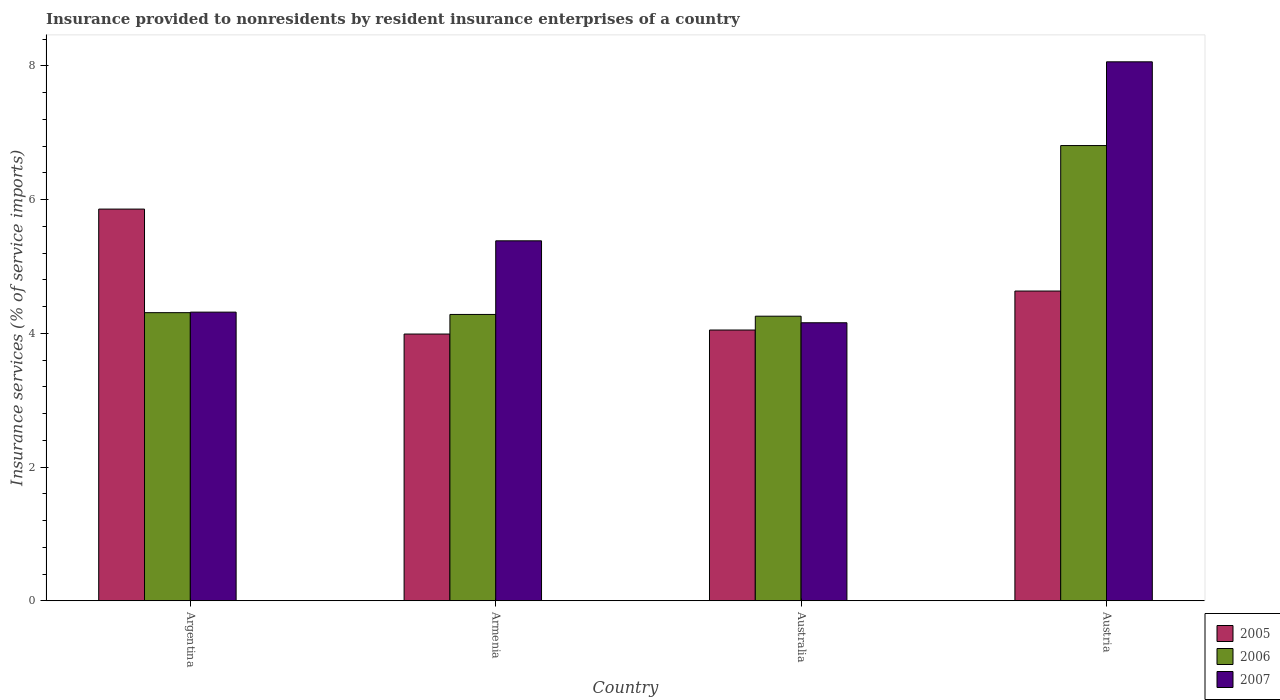How many groups of bars are there?
Your response must be concise. 4. Are the number of bars per tick equal to the number of legend labels?
Keep it short and to the point. Yes. Are the number of bars on each tick of the X-axis equal?
Make the answer very short. Yes. How many bars are there on the 2nd tick from the right?
Your answer should be very brief. 3. What is the label of the 2nd group of bars from the left?
Offer a very short reply. Armenia. In how many cases, is the number of bars for a given country not equal to the number of legend labels?
Keep it short and to the point. 0. What is the insurance provided to nonresidents in 2007 in Australia?
Provide a short and direct response. 4.16. Across all countries, what is the maximum insurance provided to nonresidents in 2005?
Make the answer very short. 5.86. Across all countries, what is the minimum insurance provided to nonresidents in 2006?
Offer a terse response. 4.26. In which country was the insurance provided to nonresidents in 2006 maximum?
Provide a succinct answer. Austria. In which country was the insurance provided to nonresidents in 2006 minimum?
Keep it short and to the point. Australia. What is the total insurance provided to nonresidents in 2006 in the graph?
Provide a short and direct response. 19.65. What is the difference between the insurance provided to nonresidents in 2006 in Armenia and that in Australia?
Your answer should be very brief. 0.03. What is the difference between the insurance provided to nonresidents in 2005 in Armenia and the insurance provided to nonresidents in 2007 in Argentina?
Provide a short and direct response. -0.33. What is the average insurance provided to nonresidents in 2007 per country?
Your answer should be compact. 5.48. What is the difference between the insurance provided to nonresidents of/in 2005 and insurance provided to nonresidents of/in 2007 in Australia?
Give a very brief answer. -0.11. What is the ratio of the insurance provided to nonresidents in 2005 in Armenia to that in Austria?
Ensure brevity in your answer.  0.86. Is the insurance provided to nonresidents in 2007 in Argentina less than that in Armenia?
Your response must be concise. Yes. What is the difference between the highest and the second highest insurance provided to nonresidents in 2005?
Your response must be concise. -0.58. What is the difference between the highest and the lowest insurance provided to nonresidents in 2006?
Provide a succinct answer. 2.55. In how many countries, is the insurance provided to nonresidents in 2007 greater than the average insurance provided to nonresidents in 2007 taken over all countries?
Your answer should be very brief. 1. Is the sum of the insurance provided to nonresidents in 2006 in Armenia and Austria greater than the maximum insurance provided to nonresidents in 2005 across all countries?
Your answer should be compact. Yes. What does the 1st bar from the right in Austria represents?
Give a very brief answer. 2007. How many bars are there?
Offer a terse response. 12. How many countries are there in the graph?
Keep it short and to the point. 4. What is the difference between two consecutive major ticks on the Y-axis?
Your response must be concise. 2. How many legend labels are there?
Provide a succinct answer. 3. What is the title of the graph?
Keep it short and to the point. Insurance provided to nonresidents by resident insurance enterprises of a country. Does "1964" appear as one of the legend labels in the graph?
Give a very brief answer. No. What is the label or title of the Y-axis?
Your response must be concise. Insurance services (% of service imports). What is the Insurance services (% of service imports) of 2005 in Argentina?
Offer a terse response. 5.86. What is the Insurance services (% of service imports) in 2006 in Argentina?
Your answer should be very brief. 4.31. What is the Insurance services (% of service imports) in 2007 in Argentina?
Make the answer very short. 4.32. What is the Insurance services (% of service imports) in 2005 in Armenia?
Offer a very short reply. 3.99. What is the Insurance services (% of service imports) of 2006 in Armenia?
Make the answer very short. 4.28. What is the Insurance services (% of service imports) of 2007 in Armenia?
Make the answer very short. 5.38. What is the Insurance services (% of service imports) in 2005 in Australia?
Provide a succinct answer. 4.05. What is the Insurance services (% of service imports) in 2006 in Australia?
Make the answer very short. 4.26. What is the Insurance services (% of service imports) of 2007 in Australia?
Ensure brevity in your answer.  4.16. What is the Insurance services (% of service imports) in 2005 in Austria?
Make the answer very short. 4.63. What is the Insurance services (% of service imports) of 2006 in Austria?
Offer a very short reply. 6.81. What is the Insurance services (% of service imports) of 2007 in Austria?
Your answer should be compact. 8.06. Across all countries, what is the maximum Insurance services (% of service imports) in 2005?
Provide a short and direct response. 5.86. Across all countries, what is the maximum Insurance services (% of service imports) of 2006?
Provide a succinct answer. 6.81. Across all countries, what is the maximum Insurance services (% of service imports) in 2007?
Your answer should be very brief. 8.06. Across all countries, what is the minimum Insurance services (% of service imports) in 2005?
Provide a succinct answer. 3.99. Across all countries, what is the minimum Insurance services (% of service imports) in 2006?
Offer a terse response. 4.26. Across all countries, what is the minimum Insurance services (% of service imports) in 2007?
Keep it short and to the point. 4.16. What is the total Insurance services (% of service imports) in 2005 in the graph?
Provide a short and direct response. 18.53. What is the total Insurance services (% of service imports) in 2006 in the graph?
Your answer should be compact. 19.65. What is the total Insurance services (% of service imports) of 2007 in the graph?
Make the answer very short. 21.92. What is the difference between the Insurance services (% of service imports) in 2005 in Argentina and that in Armenia?
Keep it short and to the point. 1.87. What is the difference between the Insurance services (% of service imports) of 2006 in Argentina and that in Armenia?
Offer a very short reply. 0.03. What is the difference between the Insurance services (% of service imports) in 2007 in Argentina and that in Armenia?
Ensure brevity in your answer.  -1.07. What is the difference between the Insurance services (% of service imports) of 2005 in Argentina and that in Australia?
Offer a terse response. 1.81. What is the difference between the Insurance services (% of service imports) in 2006 in Argentina and that in Australia?
Ensure brevity in your answer.  0.05. What is the difference between the Insurance services (% of service imports) of 2007 in Argentina and that in Australia?
Keep it short and to the point. 0.16. What is the difference between the Insurance services (% of service imports) in 2005 in Argentina and that in Austria?
Give a very brief answer. 1.23. What is the difference between the Insurance services (% of service imports) in 2006 in Argentina and that in Austria?
Provide a succinct answer. -2.5. What is the difference between the Insurance services (% of service imports) of 2007 in Argentina and that in Austria?
Your answer should be compact. -3.74. What is the difference between the Insurance services (% of service imports) in 2005 in Armenia and that in Australia?
Ensure brevity in your answer.  -0.06. What is the difference between the Insurance services (% of service imports) in 2006 in Armenia and that in Australia?
Your response must be concise. 0.03. What is the difference between the Insurance services (% of service imports) in 2007 in Armenia and that in Australia?
Make the answer very short. 1.23. What is the difference between the Insurance services (% of service imports) in 2005 in Armenia and that in Austria?
Your response must be concise. -0.64. What is the difference between the Insurance services (% of service imports) in 2006 in Armenia and that in Austria?
Ensure brevity in your answer.  -2.53. What is the difference between the Insurance services (% of service imports) of 2007 in Armenia and that in Austria?
Give a very brief answer. -2.68. What is the difference between the Insurance services (% of service imports) of 2005 in Australia and that in Austria?
Provide a succinct answer. -0.58. What is the difference between the Insurance services (% of service imports) of 2006 in Australia and that in Austria?
Give a very brief answer. -2.55. What is the difference between the Insurance services (% of service imports) in 2007 in Australia and that in Austria?
Your response must be concise. -3.9. What is the difference between the Insurance services (% of service imports) of 2005 in Argentina and the Insurance services (% of service imports) of 2006 in Armenia?
Your answer should be compact. 1.58. What is the difference between the Insurance services (% of service imports) in 2005 in Argentina and the Insurance services (% of service imports) in 2007 in Armenia?
Offer a terse response. 0.47. What is the difference between the Insurance services (% of service imports) in 2006 in Argentina and the Insurance services (% of service imports) in 2007 in Armenia?
Your answer should be compact. -1.07. What is the difference between the Insurance services (% of service imports) of 2005 in Argentina and the Insurance services (% of service imports) of 2006 in Australia?
Your response must be concise. 1.6. What is the difference between the Insurance services (% of service imports) of 2005 in Argentina and the Insurance services (% of service imports) of 2007 in Australia?
Your answer should be very brief. 1.7. What is the difference between the Insurance services (% of service imports) of 2006 in Argentina and the Insurance services (% of service imports) of 2007 in Australia?
Your answer should be very brief. 0.15. What is the difference between the Insurance services (% of service imports) in 2005 in Argentina and the Insurance services (% of service imports) in 2006 in Austria?
Ensure brevity in your answer.  -0.95. What is the difference between the Insurance services (% of service imports) of 2005 in Argentina and the Insurance services (% of service imports) of 2007 in Austria?
Your answer should be very brief. -2.2. What is the difference between the Insurance services (% of service imports) in 2006 in Argentina and the Insurance services (% of service imports) in 2007 in Austria?
Make the answer very short. -3.75. What is the difference between the Insurance services (% of service imports) in 2005 in Armenia and the Insurance services (% of service imports) in 2006 in Australia?
Offer a very short reply. -0.27. What is the difference between the Insurance services (% of service imports) in 2005 in Armenia and the Insurance services (% of service imports) in 2007 in Australia?
Your response must be concise. -0.17. What is the difference between the Insurance services (% of service imports) of 2006 in Armenia and the Insurance services (% of service imports) of 2007 in Australia?
Provide a short and direct response. 0.12. What is the difference between the Insurance services (% of service imports) of 2005 in Armenia and the Insurance services (% of service imports) of 2006 in Austria?
Keep it short and to the point. -2.82. What is the difference between the Insurance services (% of service imports) of 2005 in Armenia and the Insurance services (% of service imports) of 2007 in Austria?
Provide a succinct answer. -4.07. What is the difference between the Insurance services (% of service imports) in 2006 in Armenia and the Insurance services (% of service imports) in 2007 in Austria?
Your response must be concise. -3.78. What is the difference between the Insurance services (% of service imports) in 2005 in Australia and the Insurance services (% of service imports) in 2006 in Austria?
Your response must be concise. -2.76. What is the difference between the Insurance services (% of service imports) in 2005 in Australia and the Insurance services (% of service imports) in 2007 in Austria?
Your answer should be very brief. -4.01. What is the difference between the Insurance services (% of service imports) in 2006 in Australia and the Insurance services (% of service imports) in 2007 in Austria?
Your response must be concise. -3.8. What is the average Insurance services (% of service imports) of 2005 per country?
Provide a short and direct response. 4.63. What is the average Insurance services (% of service imports) of 2006 per country?
Your response must be concise. 4.91. What is the average Insurance services (% of service imports) in 2007 per country?
Provide a succinct answer. 5.48. What is the difference between the Insurance services (% of service imports) of 2005 and Insurance services (% of service imports) of 2006 in Argentina?
Your answer should be compact. 1.55. What is the difference between the Insurance services (% of service imports) of 2005 and Insurance services (% of service imports) of 2007 in Argentina?
Provide a succinct answer. 1.54. What is the difference between the Insurance services (% of service imports) in 2006 and Insurance services (% of service imports) in 2007 in Argentina?
Offer a terse response. -0.01. What is the difference between the Insurance services (% of service imports) in 2005 and Insurance services (% of service imports) in 2006 in Armenia?
Provide a succinct answer. -0.29. What is the difference between the Insurance services (% of service imports) in 2005 and Insurance services (% of service imports) in 2007 in Armenia?
Your answer should be compact. -1.39. What is the difference between the Insurance services (% of service imports) of 2006 and Insurance services (% of service imports) of 2007 in Armenia?
Offer a very short reply. -1.1. What is the difference between the Insurance services (% of service imports) of 2005 and Insurance services (% of service imports) of 2006 in Australia?
Your answer should be compact. -0.21. What is the difference between the Insurance services (% of service imports) of 2005 and Insurance services (% of service imports) of 2007 in Australia?
Your answer should be compact. -0.11. What is the difference between the Insurance services (% of service imports) of 2006 and Insurance services (% of service imports) of 2007 in Australia?
Give a very brief answer. 0.1. What is the difference between the Insurance services (% of service imports) of 2005 and Insurance services (% of service imports) of 2006 in Austria?
Your answer should be compact. -2.18. What is the difference between the Insurance services (% of service imports) of 2005 and Insurance services (% of service imports) of 2007 in Austria?
Keep it short and to the point. -3.43. What is the difference between the Insurance services (% of service imports) of 2006 and Insurance services (% of service imports) of 2007 in Austria?
Provide a short and direct response. -1.25. What is the ratio of the Insurance services (% of service imports) in 2005 in Argentina to that in Armenia?
Offer a terse response. 1.47. What is the ratio of the Insurance services (% of service imports) of 2006 in Argentina to that in Armenia?
Your answer should be compact. 1.01. What is the ratio of the Insurance services (% of service imports) of 2007 in Argentina to that in Armenia?
Provide a succinct answer. 0.8. What is the ratio of the Insurance services (% of service imports) in 2005 in Argentina to that in Australia?
Provide a succinct answer. 1.45. What is the ratio of the Insurance services (% of service imports) of 2006 in Argentina to that in Australia?
Ensure brevity in your answer.  1.01. What is the ratio of the Insurance services (% of service imports) of 2007 in Argentina to that in Australia?
Ensure brevity in your answer.  1.04. What is the ratio of the Insurance services (% of service imports) of 2005 in Argentina to that in Austria?
Your answer should be compact. 1.26. What is the ratio of the Insurance services (% of service imports) of 2006 in Argentina to that in Austria?
Provide a succinct answer. 0.63. What is the ratio of the Insurance services (% of service imports) in 2007 in Argentina to that in Austria?
Provide a succinct answer. 0.54. What is the ratio of the Insurance services (% of service imports) of 2005 in Armenia to that in Australia?
Offer a terse response. 0.99. What is the ratio of the Insurance services (% of service imports) in 2007 in Armenia to that in Australia?
Ensure brevity in your answer.  1.29. What is the ratio of the Insurance services (% of service imports) of 2005 in Armenia to that in Austria?
Make the answer very short. 0.86. What is the ratio of the Insurance services (% of service imports) of 2006 in Armenia to that in Austria?
Provide a short and direct response. 0.63. What is the ratio of the Insurance services (% of service imports) of 2007 in Armenia to that in Austria?
Offer a very short reply. 0.67. What is the ratio of the Insurance services (% of service imports) of 2005 in Australia to that in Austria?
Your answer should be very brief. 0.87. What is the ratio of the Insurance services (% of service imports) of 2006 in Australia to that in Austria?
Offer a terse response. 0.63. What is the ratio of the Insurance services (% of service imports) of 2007 in Australia to that in Austria?
Your response must be concise. 0.52. What is the difference between the highest and the second highest Insurance services (% of service imports) in 2005?
Make the answer very short. 1.23. What is the difference between the highest and the second highest Insurance services (% of service imports) in 2006?
Offer a terse response. 2.5. What is the difference between the highest and the second highest Insurance services (% of service imports) of 2007?
Your response must be concise. 2.68. What is the difference between the highest and the lowest Insurance services (% of service imports) of 2005?
Your response must be concise. 1.87. What is the difference between the highest and the lowest Insurance services (% of service imports) of 2006?
Provide a short and direct response. 2.55. What is the difference between the highest and the lowest Insurance services (% of service imports) in 2007?
Your response must be concise. 3.9. 